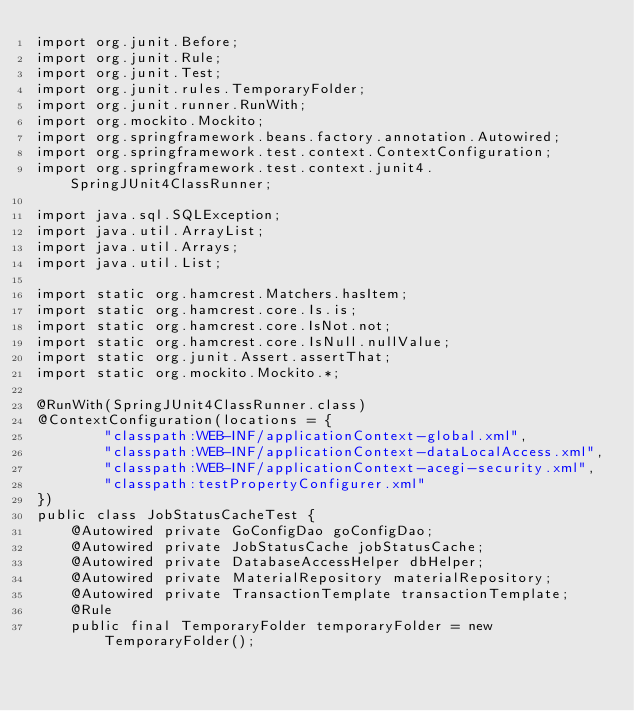<code> <loc_0><loc_0><loc_500><loc_500><_Java_>import org.junit.Before;
import org.junit.Rule;
import org.junit.Test;
import org.junit.rules.TemporaryFolder;
import org.junit.runner.RunWith;
import org.mockito.Mockito;
import org.springframework.beans.factory.annotation.Autowired;
import org.springframework.test.context.ContextConfiguration;
import org.springframework.test.context.junit4.SpringJUnit4ClassRunner;

import java.sql.SQLException;
import java.util.ArrayList;
import java.util.Arrays;
import java.util.List;

import static org.hamcrest.Matchers.hasItem;
import static org.hamcrest.core.Is.is;
import static org.hamcrest.core.IsNot.not;
import static org.hamcrest.core.IsNull.nullValue;
import static org.junit.Assert.assertThat;
import static org.mockito.Mockito.*;

@RunWith(SpringJUnit4ClassRunner.class)
@ContextConfiguration(locations = {
        "classpath:WEB-INF/applicationContext-global.xml",
        "classpath:WEB-INF/applicationContext-dataLocalAccess.xml",
        "classpath:WEB-INF/applicationContext-acegi-security.xml",
        "classpath:testPropertyConfigurer.xml"
})
public class JobStatusCacheTest {
    @Autowired private GoConfigDao goConfigDao;
    @Autowired private JobStatusCache jobStatusCache;
    @Autowired private DatabaseAccessHelper dbHelper;
    @Autowired private MaterialRepository materialRepository;
    @Autowired private TransactionTemplate transactionTemplate;
    @Rule
    public final TemporaryFolder temporaryFolder = new TemporaryFolder();
</code> 